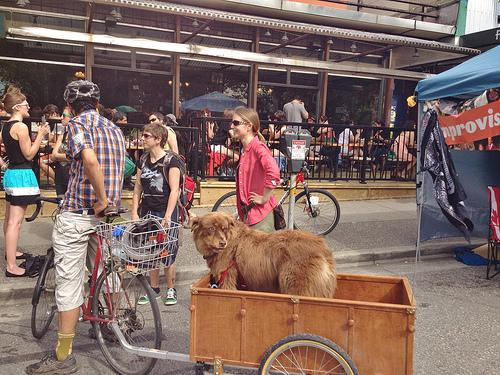Question: what kind of animals is riding in the cart?
Choices:
A. A wolf.
B. The cow.
C. A dog.
D. A rooster.
Answer with the letter. Answer: C Question: what color is the dog in the cart?
Choices:
A. Gold.
B. White.
C. Brown.
D. Black.
Answer with the letter. Answer: A Question: what color is the dog's collar?
Choices:
A. Blue.
B. Orange.
C. Red.
D. Yellow.
Answer with the letter. Answer: C Question: what kind of vehicle is pulling the dog cart?
Choices:
A. Unicycle.
B. A bike.
C. Motorcycle.
D. Moped.
Answer with the letter. Answer: B Question: what color sweater does the woman in the middle of the picture have on?
Choices:
A. Purple.
B. Pink.
C. Red.
D. Blue.
Answer with the letter. Answer: B Question: where is the tent in the picture?
Choices:
A. To the left.
B. To the right.
C. In the distance.
D. Cannot be seen.
Answer with the letter. Answer: B 